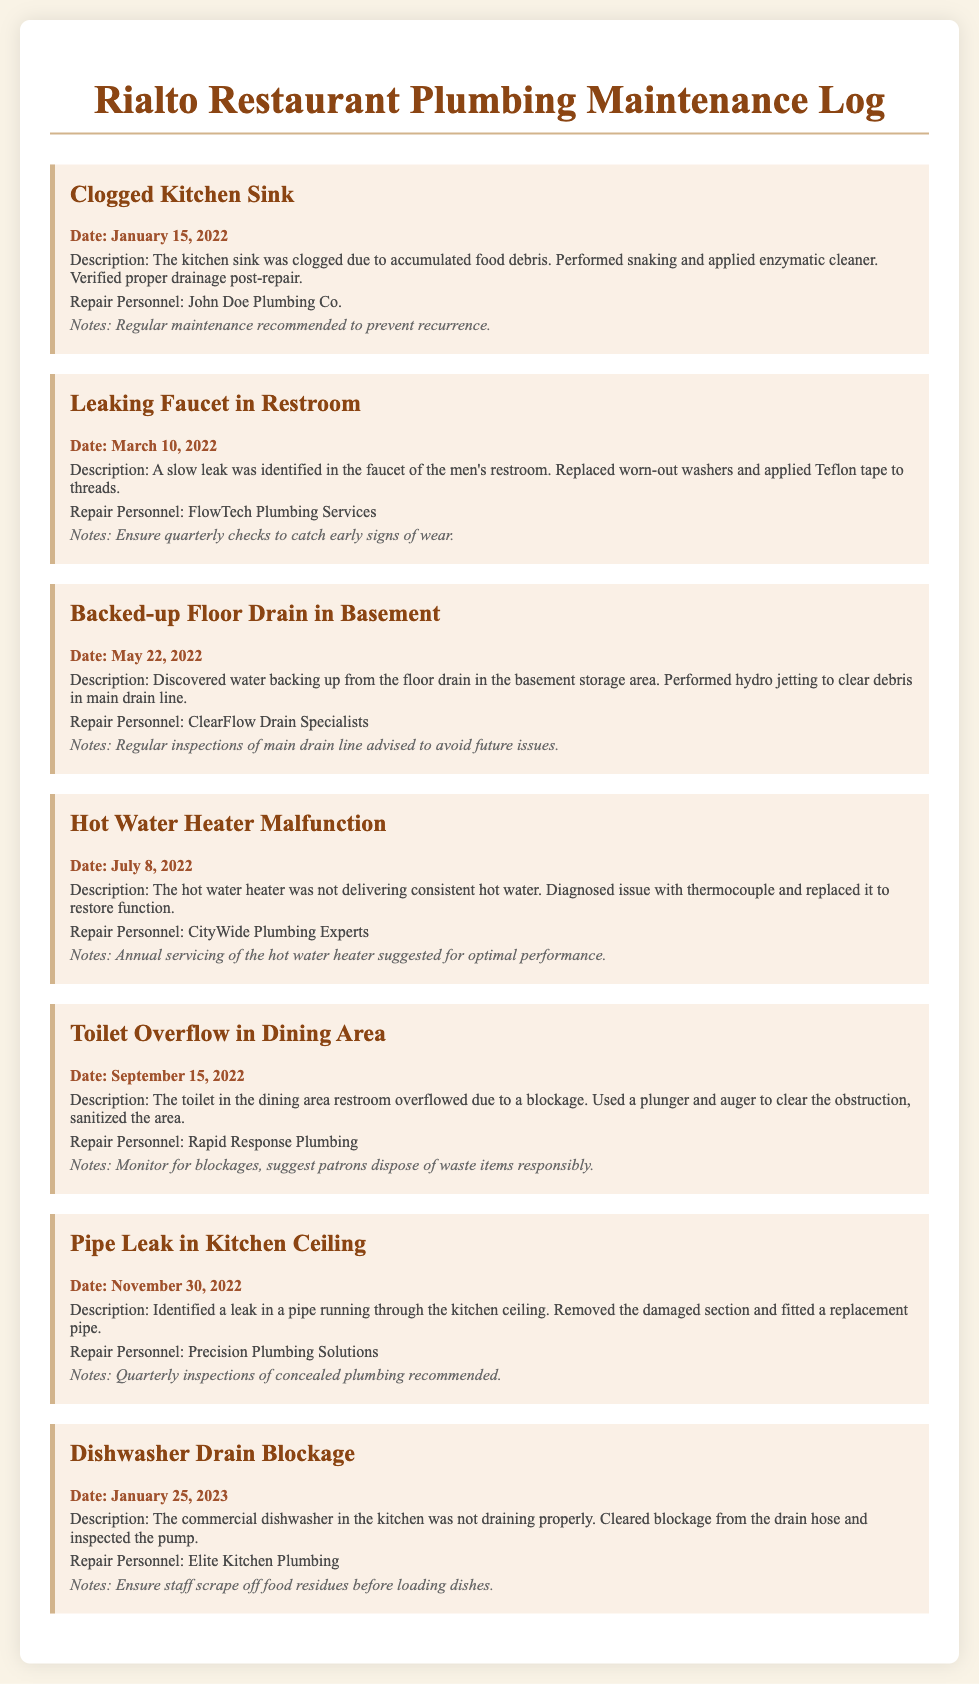What issue was reported on January 15, 2022? The issue recorded on this date was a clogged kitchen sink due to accumulated food debris.
Answer: Clogged Kitchen Sink Who performed the repair for the leaking faucet in the restroom? The repair for the leaking faucet in the restroom was performed by FlowTech Plumbing Services.
Answer: FlowTech Plumbing Services What maintenance action was taken on May 22, 2022? Hydro jetting was performed to clear debris in the main drain line due to a backed-up floor drain.
Answer: Hydro jetting How many plumbing issues required emergency repairs in 2022? There were six plumbing issues documented for emergency repairs throughout 2022.
Answer: Six What recommendation was made after the hot water heater malfunction? The maintenance log suggests annual servicing of the hot water heater for optimal performance.
Answer: Annual servicing What was the date of the dishwasher drain blockage issue? The dishwasher drain blockage was reported on January 25, 2023.
Answer: January 25, 2023 What type of plumbing problem involved the dining area restroom? The plumbing problem in the dining area restroom was an overflow due to a blockage in the toilet.
Answer: Toilet Overflow What important note was made regarding the dishwasher? It was noted that staff should scrape off food residues before loading dishes into the dishwasher.
Answer: Scrape off food residues 